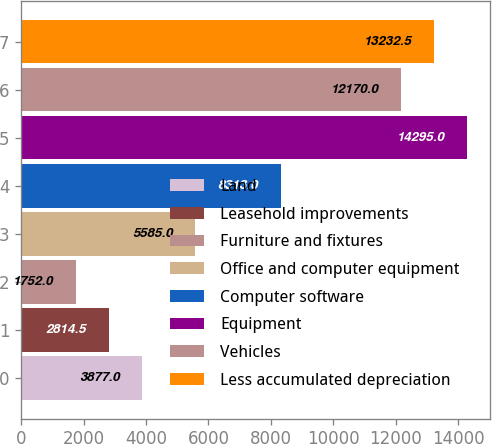<chart> <loc_0><loc_0><loc_500><loc_500><bar_chart><fcel>Land<fcel>Leasehold improvements<fcel>Furniture and fixtures<fcel>Office and computer equipment<fcel>Computer software<fcel>Equipment<fcel>Vehicles<fcel>Less accumulated depreciation<nl><fcel>3877<fcel>2814.5<fcel>1752<fcel>5585<fcel>8313<fcel>14295<fcel>12170<fcel>13232.5<nl></chart> 